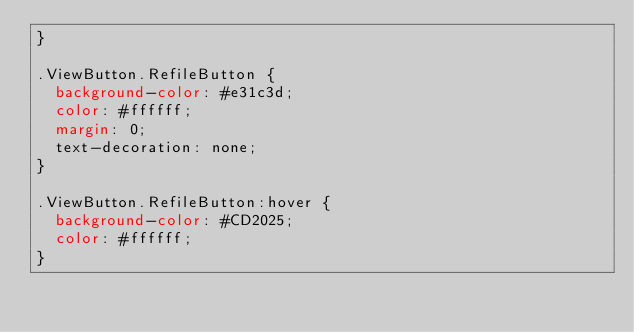Convert code to text. <code><loc_0><loc_0><loc_500><loc_500><_CSS_>}

.ViewButton.RefileButton {
  background-color: #e31c3d;
  color: #ffffff;
  margin: 0;
  text-decoration: none;
}

.ViewButton.RefileButton:hover {
  background-color: #CD2025;
  color: #ffffff;
}
</code> 